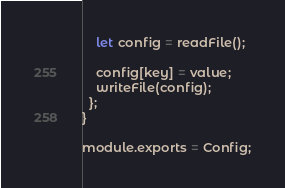<code> <loc_0><loc_0><loc_500><loc_500><_JavaScript_>    let config = readFile();

    config[key] = value;
    writeFile(config);
  };
}

module.exports = Config;
</code> 